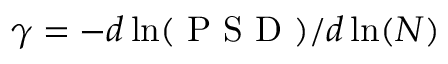<formula> <loc_0><loc_0><loc_500><loc_500>\gamma = - d \ln ( P S D ) / d \ln ( N )</formula> 